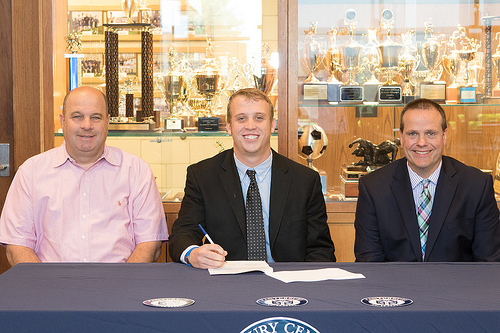<image>
Can you confirm if the man is to the left of the man? Yes. From this viewpoint, the man is positioned to the left side relative to the man. Is there a suit behind the man? No. The suit is not behind the man. From this viewpoint, the suit appears to be positioned elsewhere in the scene. 